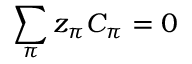<formula> <loc_0><loc_0><loc_500><loc_500>\sum _ { \pi } z _ { \pi } C _ { \pi } = 0</formula> 